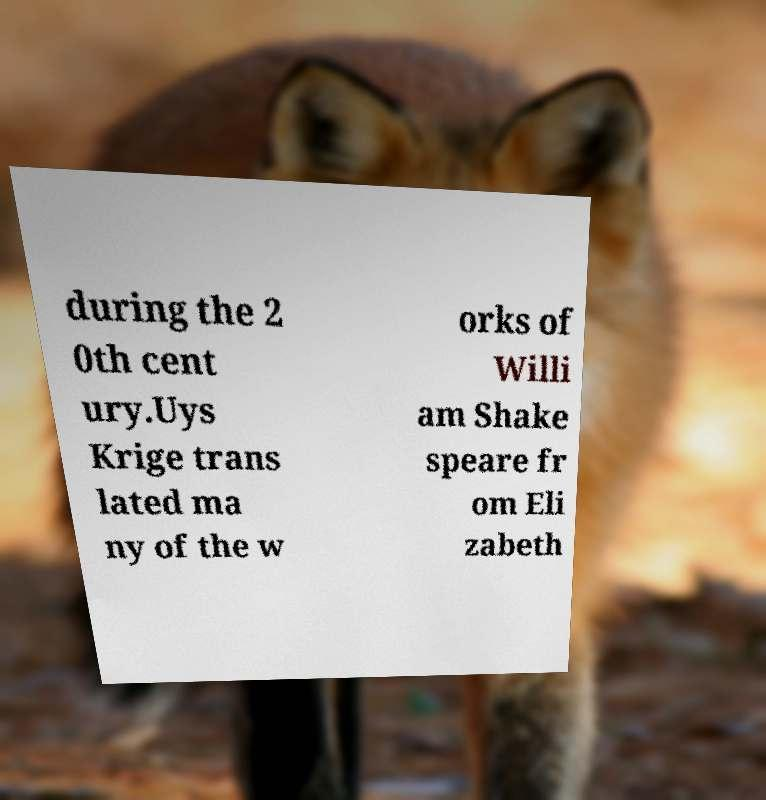Could you assist in decoding the text presented in this image and type it out clearly? during the 2 0th cent ury.Uys Krige trans lated ma ny of the w orks of Willi am Shake speare fr om Eli zabeth 